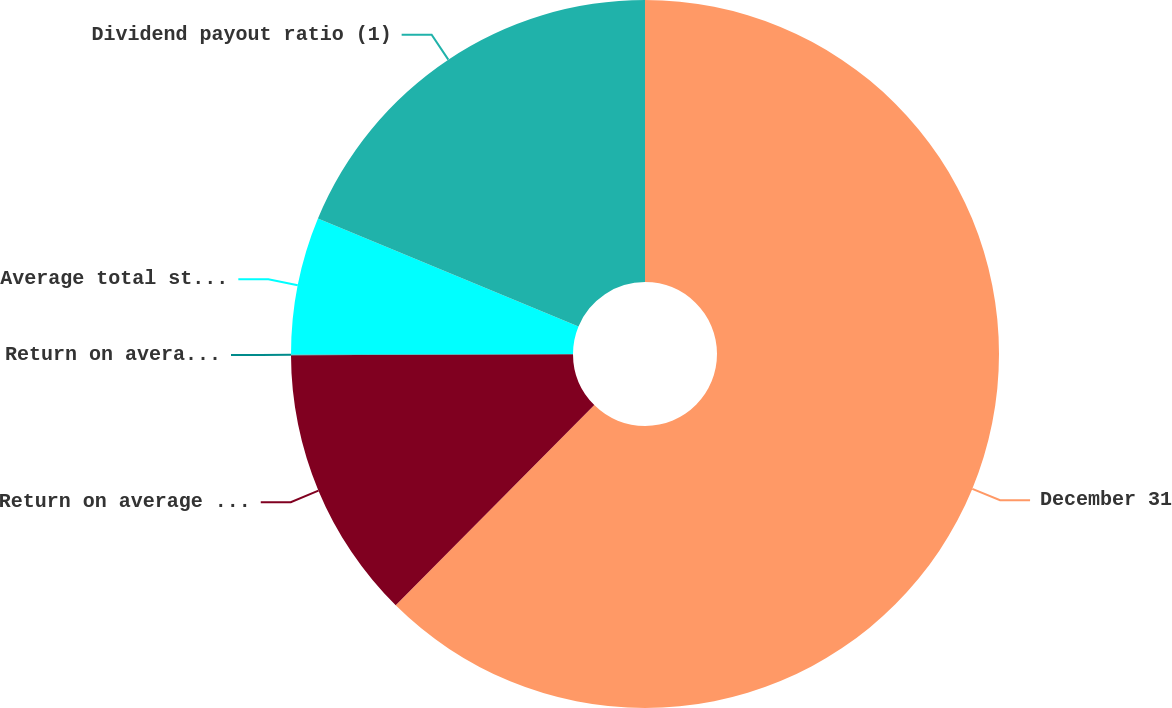<chart> <loc_0><loc_0><loc_500><loc_500><pie_chart><fcel>December 31<fcel>Return on average total<fcel>Return on average total assets<fcel>Average total stockholders'<fcel>Dividend payout ratio (1)<nl><fcel>62.43%<fcel>12.51%<fcel>0.03%<fcel>6.27%<fcel>18.75%<nl></chart> 